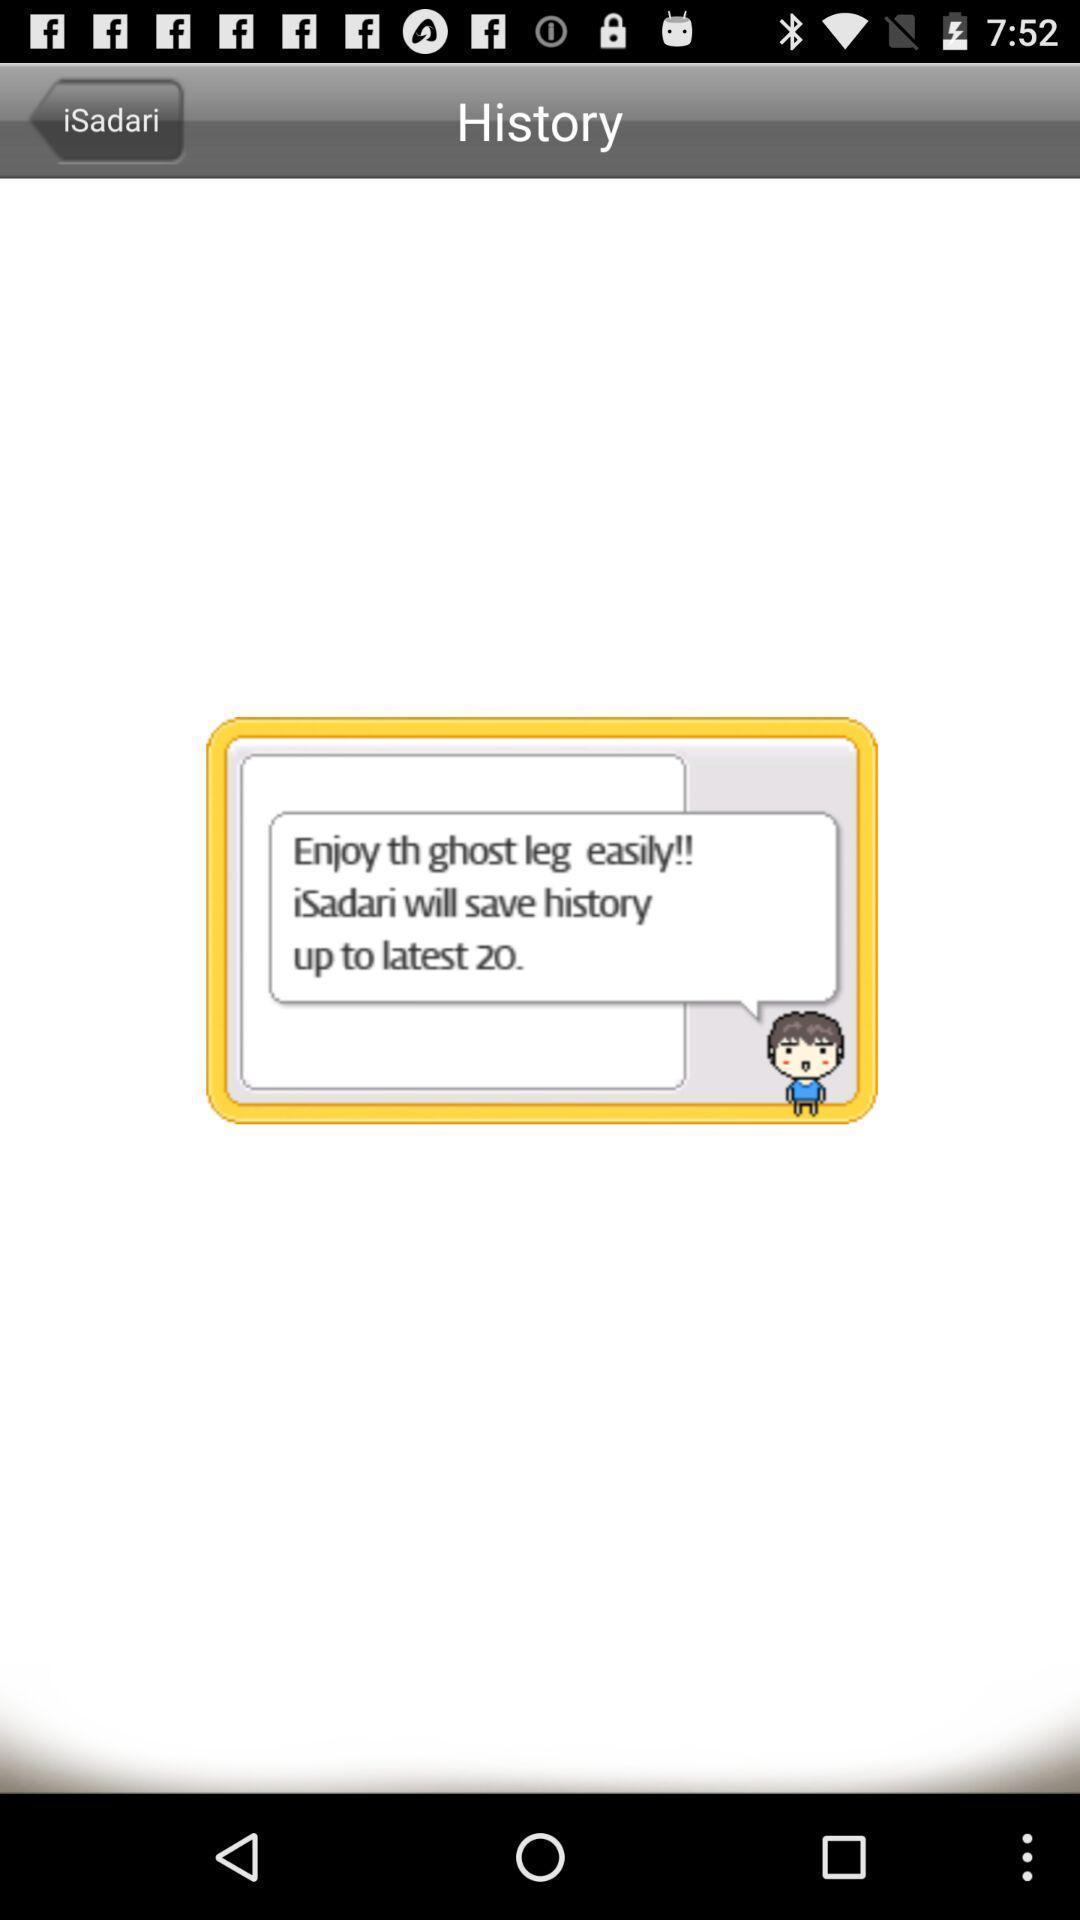Describe the key features of this screenshot. Screen page. 